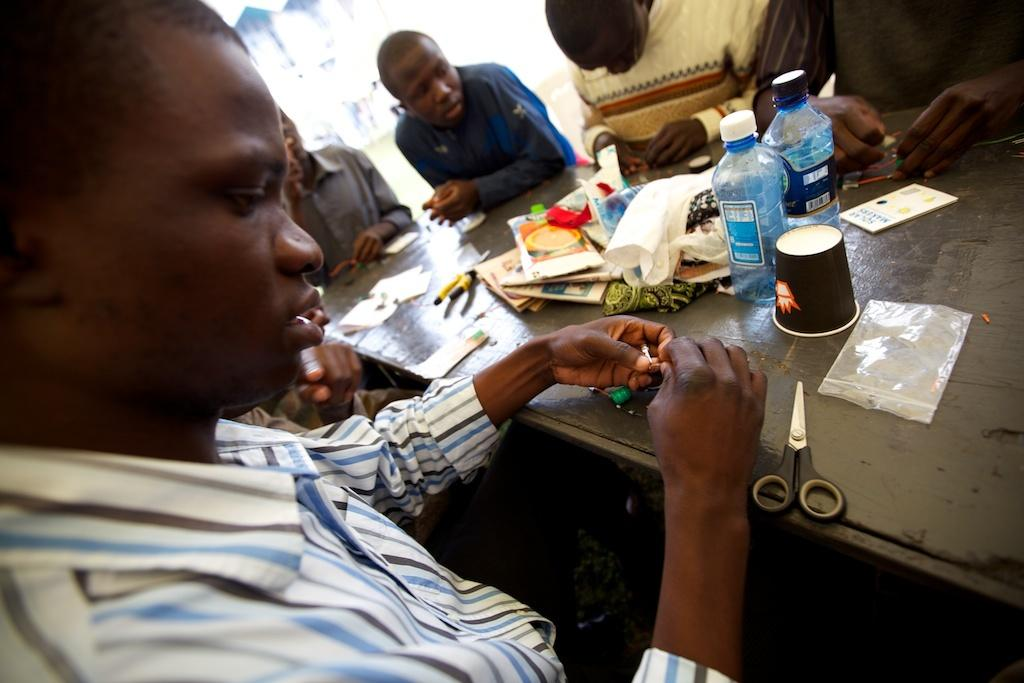What are the people in the image doing? The people in the image are sitting on chairs. What is the main piece of furniture in the image? There is a table in the image. What objects can be seen on the table? There are scissors, a cover, a glass, bottles, a book, tissues, and papers on the table. How many sheep are visible in the image? There are no sheep present in the image. What type of pot is used to hold the tissues on the table? There is no pot present in the image; the tissues are on the table without a pot. 